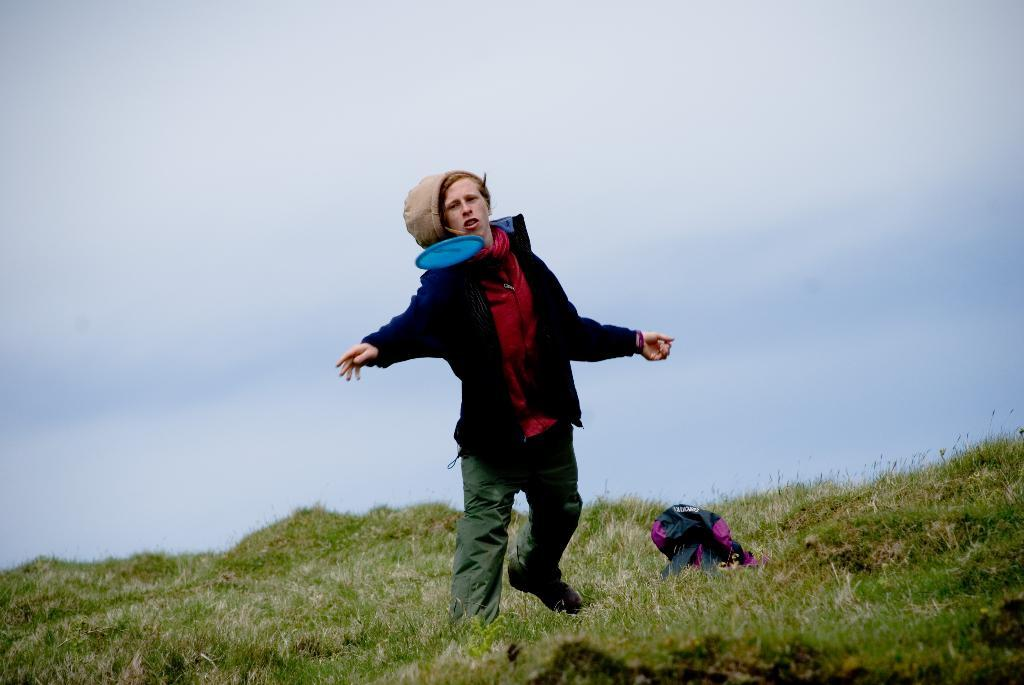What is the main subject of the image? There is a man standing on the ground in the image. What is happening in the image? A Frisbee disc is in the air in the image. What is located on the ground in the image? There is a bag on the ground in the image. What can be seen in the background of the image? The sky with clouds is visible in the background of the image. What type of butter is being spread on the bag in the image? There is no butter present in the image. 